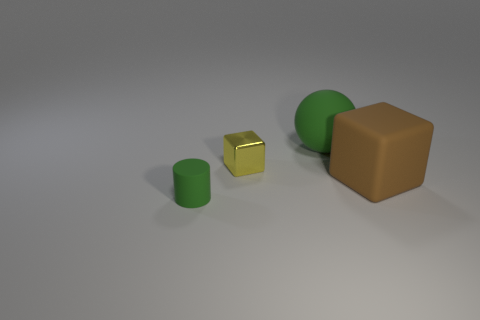Add 1 tiny green objects. How many objects exist? 5 Subtract all spheres. How many objects are left? 3 Subtract 0 brown cylinders. How many objects are left? 4 Subtract all small cyan cylinders. Subtract all green things. How many objects are left? 2 Add 2 small yellow blocks. How many small yellow blocks are left? 3 Add 2 tiny shiny things. How many tiny shiny things exist? 3 